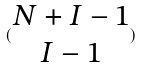<formula> <loc_0><loc_0><loc_500><loc_500>( \begin{matrix} N + I - 1 \\ I - 1 \end{matrix} )</formula> 